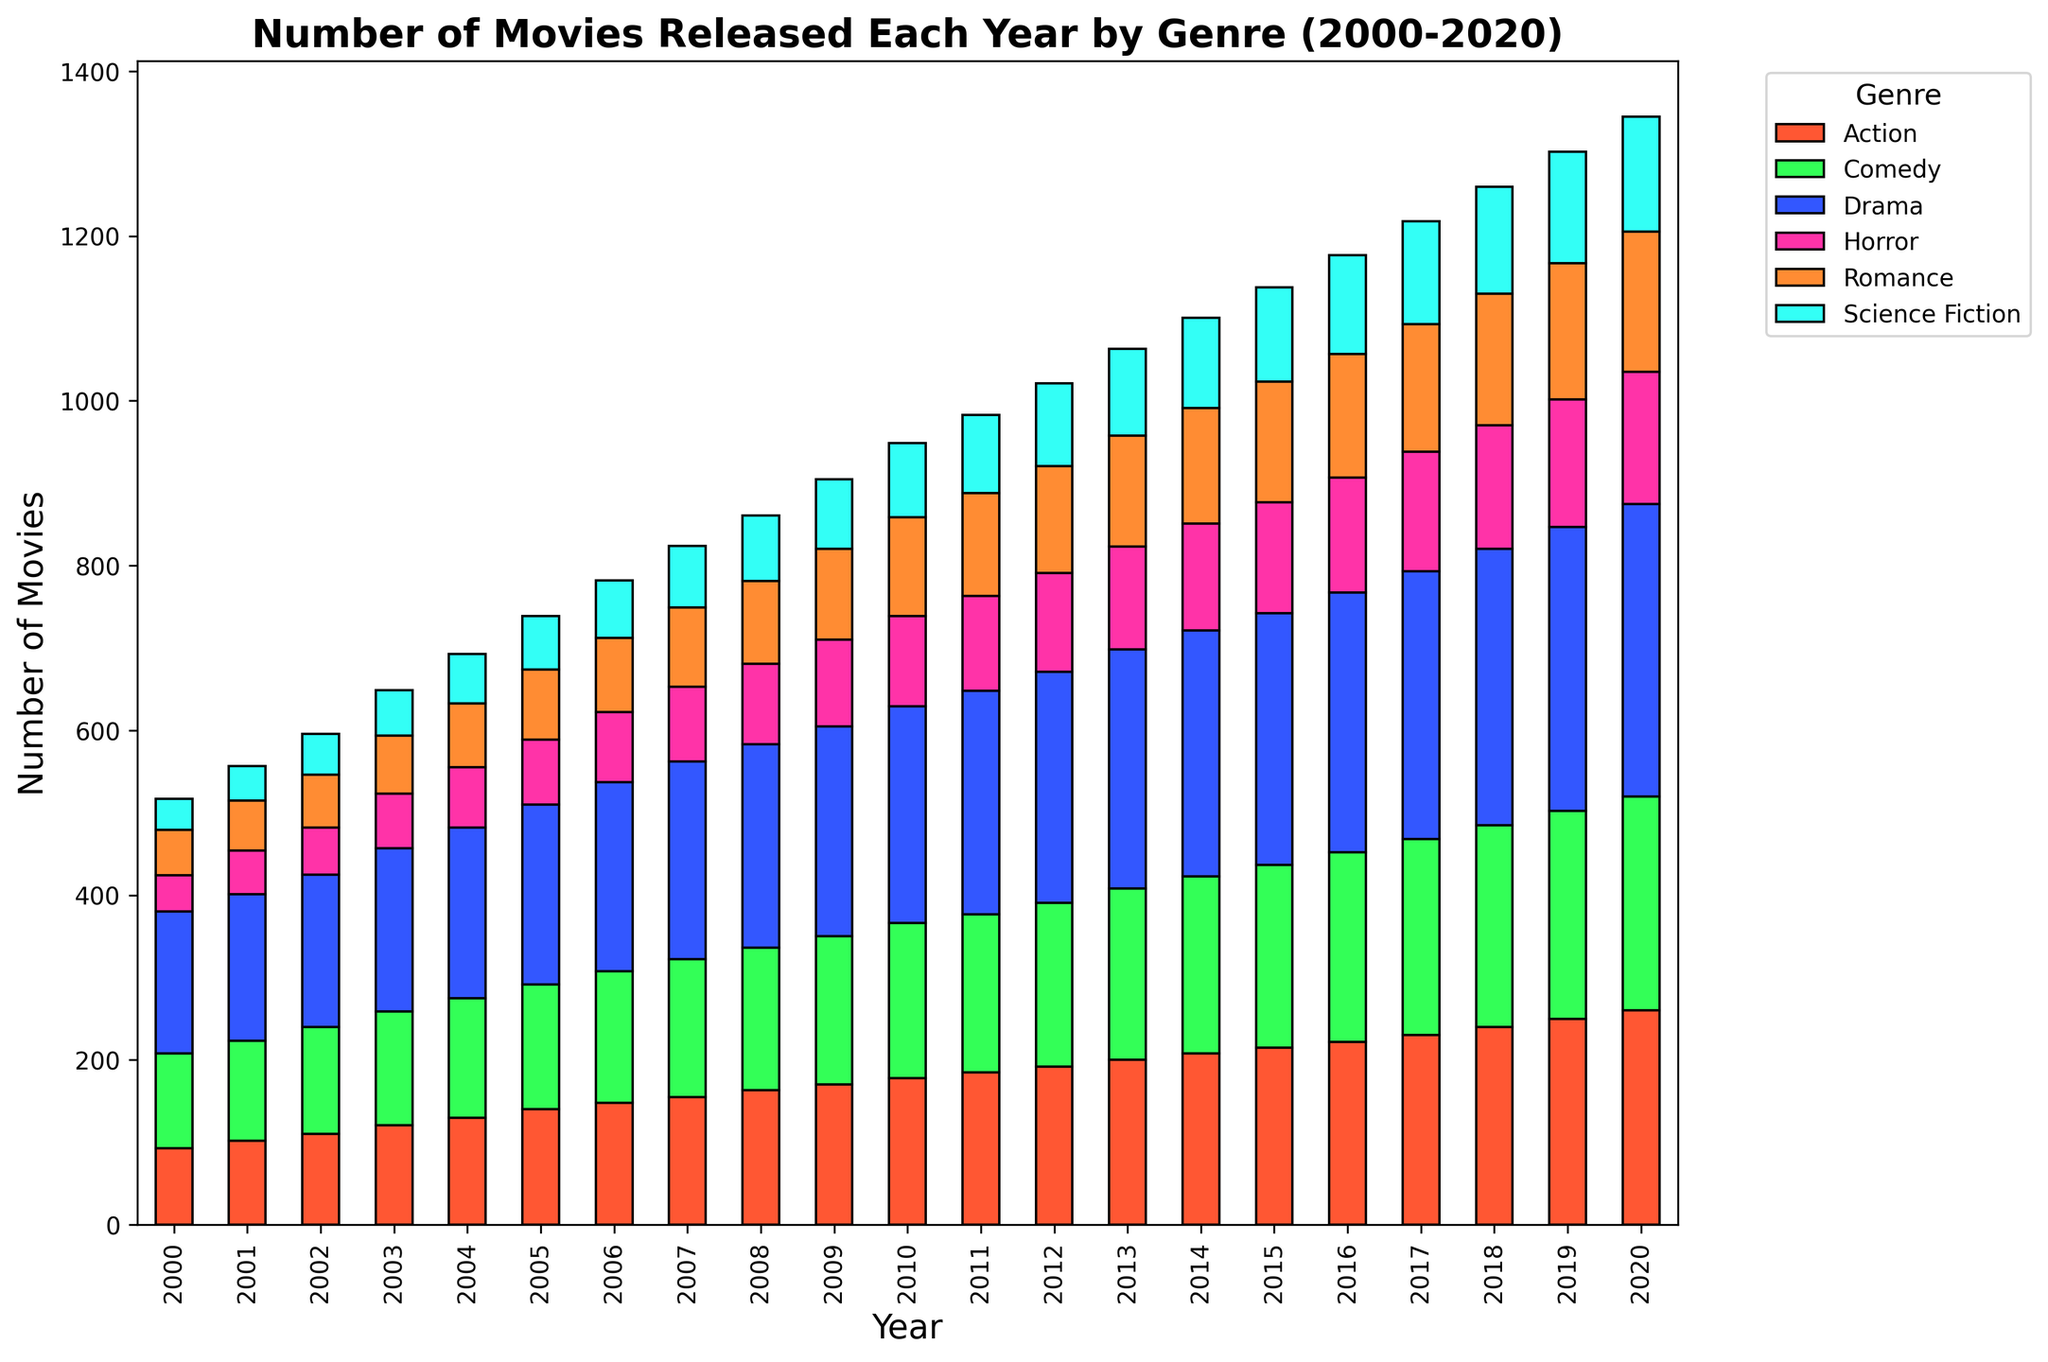What year had the most total movies released across all genres? By looking at the height of the stacks in the bar chart, the year with the highest stack of bars represents the year with the most total movies released. The year 2020 has the tallest stack.
Answer: 2020 How many more Drama movies were released in 2020 compared to 2000? From the chart, we identify the heights of the Drama bars for the years 2020 and 2000. The difference can be calculated by subtracting the 2000 value (172) from the 2020 value (355).
Answer: 183 Which genre saw the largest increase in the number of movies released from 2000 to 2020? Compare the height differences between the bars of each genre from 2000 and 2020. The genre with the most significant increase is Drama, increasing from 172 to 355 movies.
Answer: Drama Is there a year when the number of Comedy movies released was equal to the number of Science Fiction movies released? Look for any year where the height of the Comedy bar matches the height of the Science Fiction bar. There is no year where the heights are equal.
Answer: No In which year did the Horror genre see its biggest jump in movie releases compared to the previous year? Examine the changes in the height of the Horror bar year-over-year and find the year where the change is largest. The year 2009 saw the biggest jump, increasing by 15 movies from 2008 (98 to 113).
Answer: 2009 Compare the number of Romance and Horror movies released in 2010. Which genre had more movies released? Look at the bar heights for Romance and Horror in 2010. The Romance bar is taller than the Horror bar.
Answer: Romance What's the average number of Action movies released per year over the entire period (2000-2020)? To find the average, add up the number of Action movies released each year (sum = 4055) and then divide by the number of years (21).
Answer: 193 Is there any year where the number of Action movies released is less than the number of Horror movies released? Compare the heights of the Action and Horror bars for each year. There is no year where the Horror bars are taller than the Action bars.
Answer: No Which two consecutive years saw the highest growth in the total number of movies released? Identify the tallest bars' differences between all pairs of consecutive years. Compare these differences to find the largest. The jump from 2018 to 2019 shows the greatest growth in total movies released.
Answer: 2018-2019 